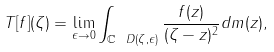Convert formula to latex. <formula><loc_0><loc_0><loc_500><loc_500>T [ f ] ( \zeta ) = \lim _ { \epsilon \rightarrow 0 } \int _ { \mathbb { C } \ D ( \zeta , \epsilon ) } \frac { f ( z ) } { ( \zeta - z ) ^ { 2 } } d m ( z ) ,</formula> 